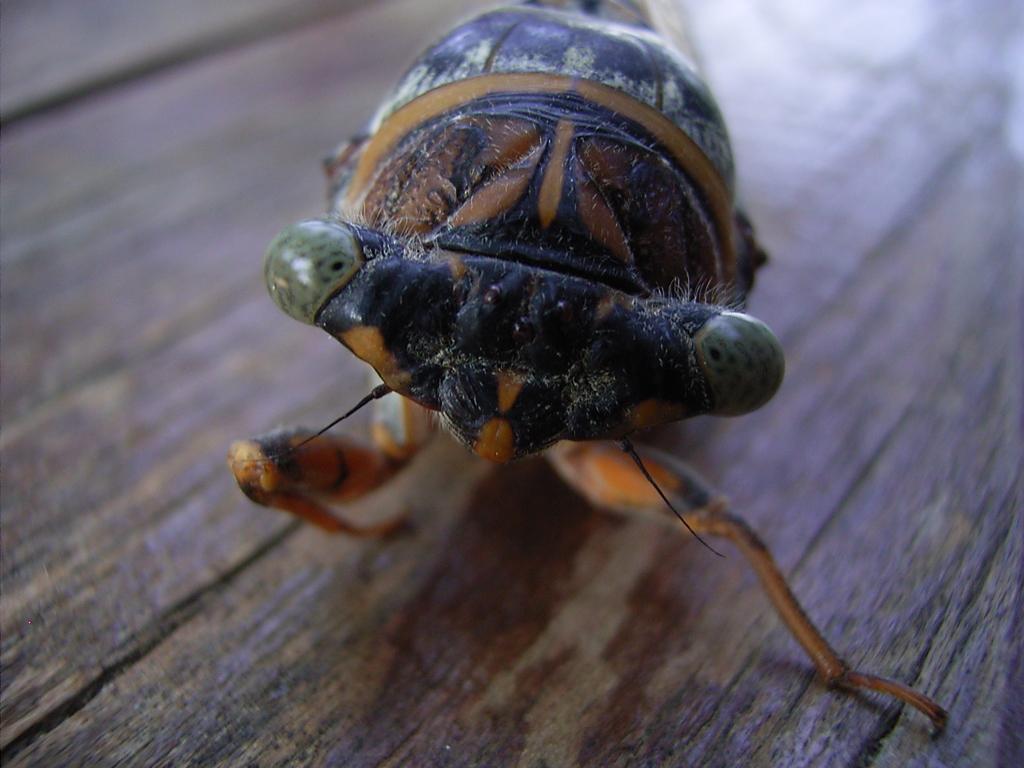In one or two sentences, can you explain what this image depicts? In the image there is an insect on the wooden surface. 